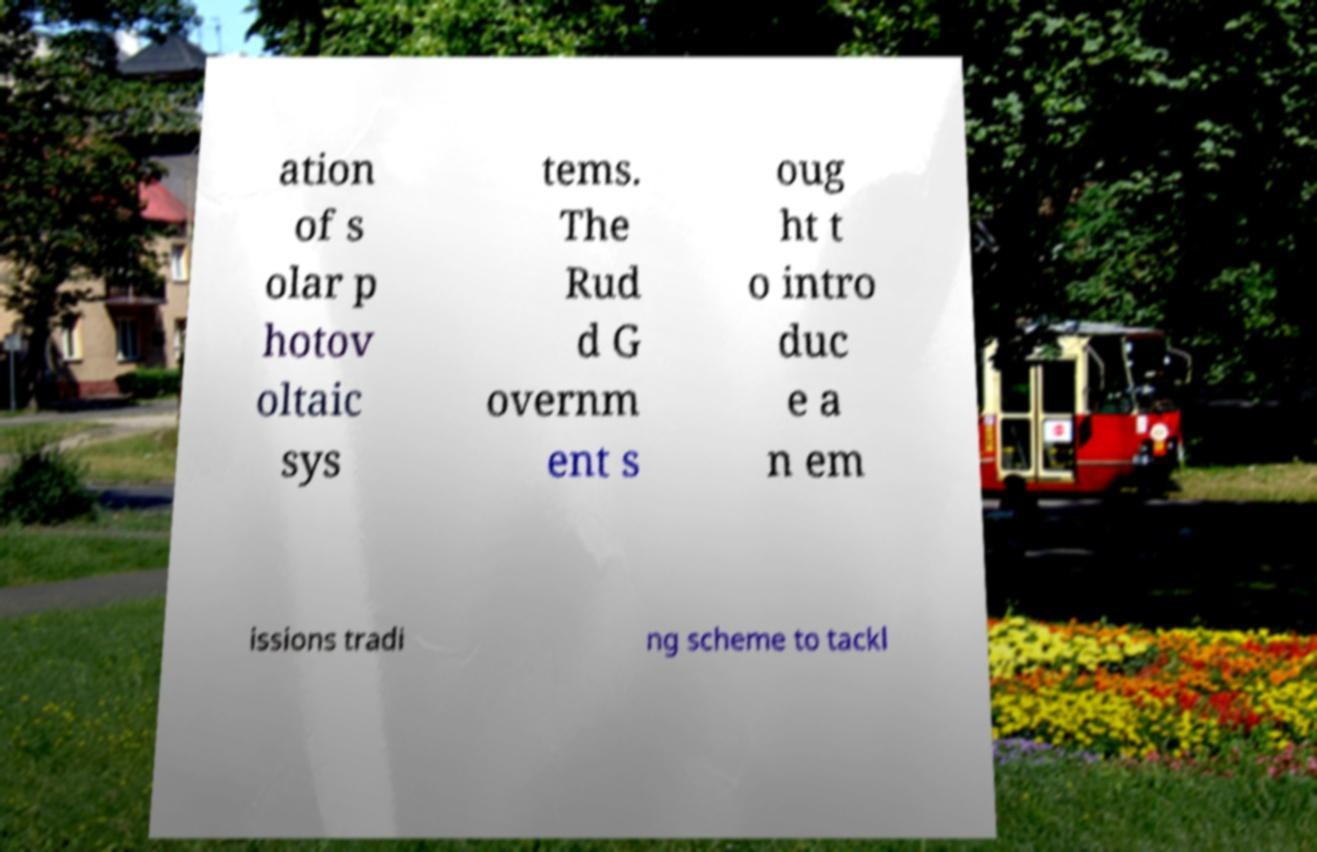Can you read and provide the text displayed in the image?This photo seems to have some interesting text. Can you extract and type it out for me? ation of s olar p hotov oltaic sys tems. The Rud d G overnm ent s oug ht t o intro duc e a n em issions tradi ng scheme to tackl 